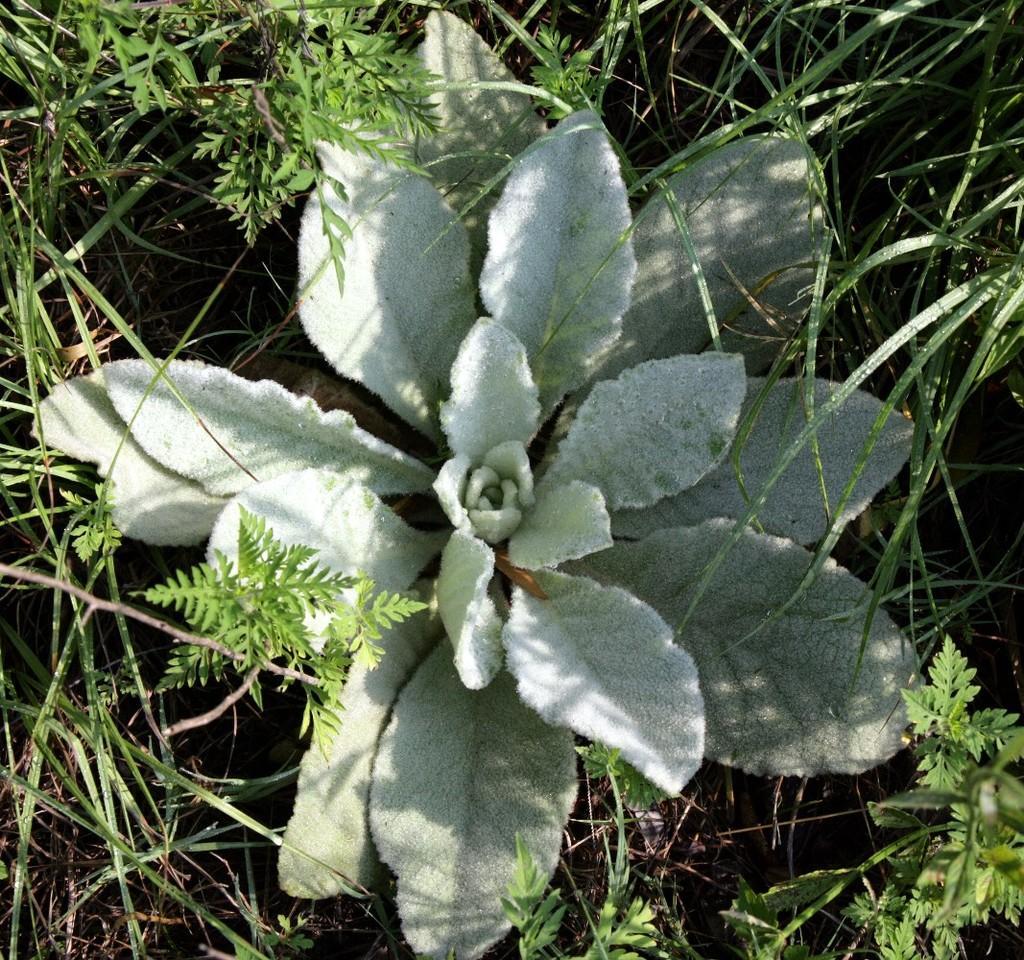Please provide a concise description of this image. In this image on the ground there are many plants and grasses. 